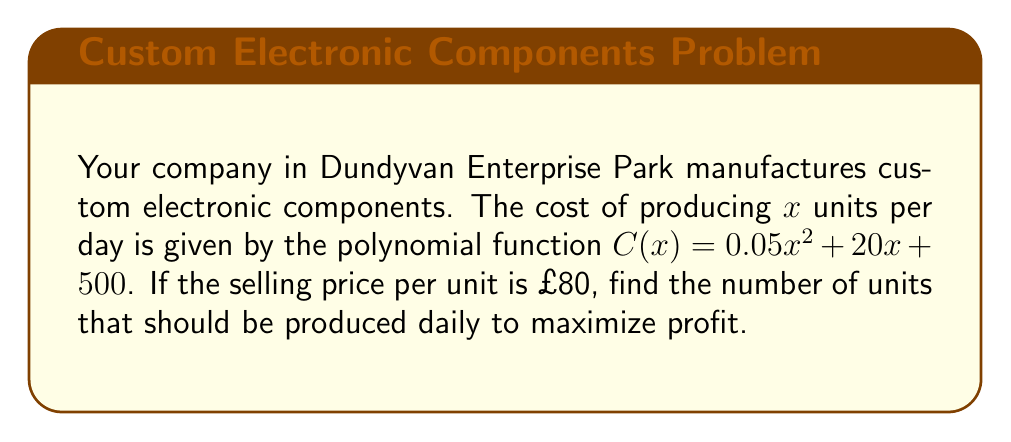Give your solution to this math problem. To solve this problem, we'll follow these steps:

1) The profit function P(x) is the difference between revenue R(x) and cost C(x):
   
   $P(x) = R(x) - C(x)$

2) Revenue is the product of price per unit and number of units:
   
   $R(x) = 80x$

3) Substituting the given cost function and revenue:
   
   $P(x) = 80x - (0.05x^2 + 20x + 500)$
   $P(x) = 80x - 0.05x^2 - 20x - 500$
   $P(x) = -0.05x^2 + 60x - 500$

4) To find the maximum profit, we need to find the vertex of this quadratic function. The x-coordinate of the vertex will give us the optimal number of units.

5) For a quadratic function in the form $ax^2 + bx + c$, the x-coordinate of the vertex is given by $-b/(2a)$.

6) In our profit function, $a = -0.05$ and $b = 60$. So:
   
   $x = -60 / (2(-0.05)) = 60 / 0.1 = 600$

Therefore, the company should produce 600 units per day to maximize profit.
Answer: 600 units 